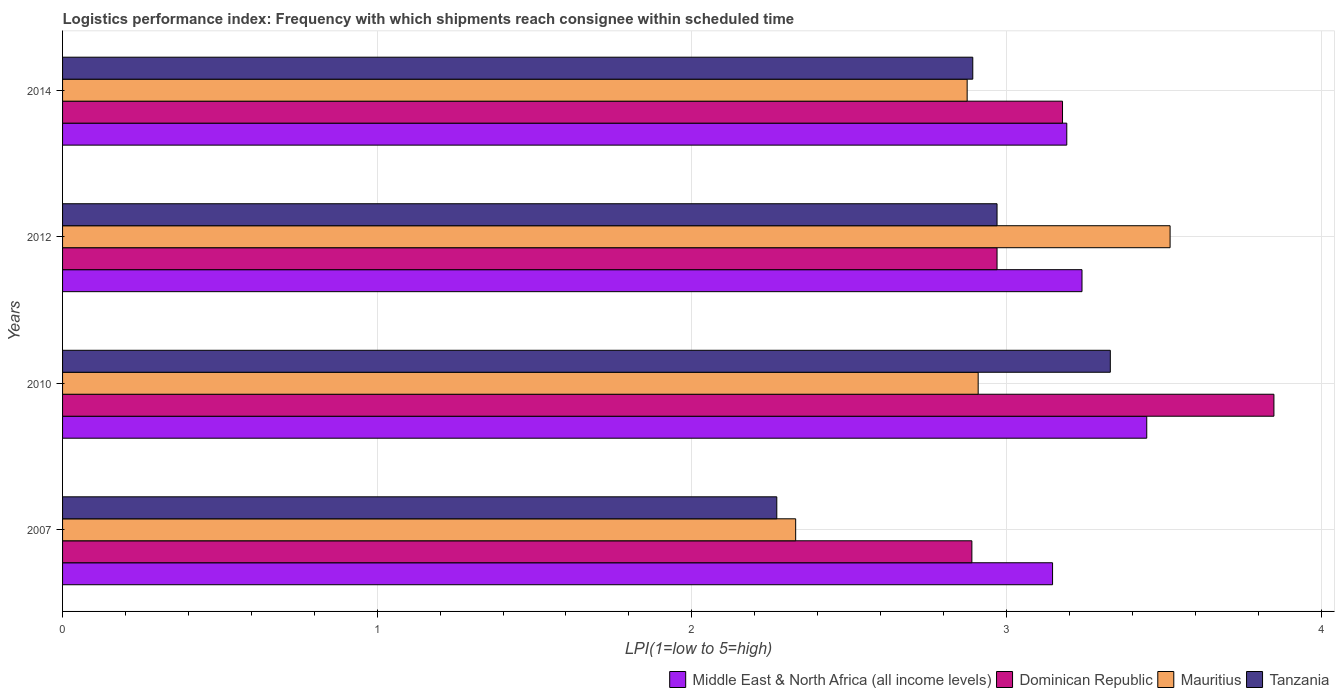Are the number of bars per tick equal to the number of legend labels?
Keep it short and to the point. Yes. Are the number of bars on each tick of the Y-axis equal?
Ensure brevity in your answer.  Yes. How many bars are there on the 4th tick from the top?
Ensure brevity in your answer.  4. In how many cases, is the number of bars for a given year not equal to the number of legend labels?
Offer a terse response. 0. What is the logistics performance index in Tanzania in 2007?
Ensure brevity in your answer.  2.27. Across all years, what is the maximum logistics performance index in Mauritius?
Offer a terse response. 3.52. Across all years, what is the minimum logistics performance index in Dominican Republic?
Your answer should be very brief. 2.89. In which year was the logistics performance index in Middle East & North Africa (all income levels) maximum?
Your response must be concise. 2010. What is the total logistics performance index in Dominican Republic in the graph?
Provide a succinct answer. 12.89. What is the difference between the logistics performance index in Tanzania in 2007 and that in 2014?
Provide a short and direct response. -0.62. What is the difference between the logistics performance index in Mauritius in 2010 and the logistics performance index in Tanzania in 2014?
Provide a short and direct response. 0.02. What is the average logistics performance index in Mauritius per year?
Offer a very short reply. 2.91. In the year 2010, what is the difference between the logistics performance index in Middle East & North Africa (all income levels) and logistics performance index in Mauritius?
Offer a terse response. 0.54. What is the ratio of the logistics performance index in Mauritius in 2007 to that in 2010?
Your response must be concise. 0.8. What is the difference between the highest and the second highest logistics performance index in Dominican Republic?
Ensure brevity in your answer.  0.67. What is the difference between the highest and the lowest logistics performance index in Tanzania?
Your answer should be compact. 1.06. In how many years, is the logistics performance index in Mauritius greater than the average logistics performance index in Mauritius taken over all years?
Give a very brief answer. 2. What does the 3rd bar from the top in 2010 represents?
Give a very brief answer. Dominican Republic. What does the 1st bar from the bottom in 2007 represents?
Provide a short and direct response. Middle East & North Africa (all income levels). Is it the case that in every year, the sum of the logistics performance index in Tanzania and logistics performance index in Middle East & North Africa (all income levels) is greater than the logistics performance index in Dominican Republic?
Your response must be concise. Yes. Are all the bars in the graph horizontal?
Keep it short and to the point. Yes. Are the values on the major ticks of X-axis written in scientific E-notation?
Keep it short and to the point. No. Does the graph contain grids?
Your answer should be compact. Yes. Where does the legend appear in the graph?
Provide a short and direct response. Bottom right. How are the legend labels stacked?
Your answer should be compact. Horizontal. What is the title of the graph?
Provide a succinct answer. Logistics performance index: Frequency with which shipments reach consignee within scheduled time. Does "Middle income" appear as one of the legend labels in the graph?
Offer a very short reply. No. What is the label or title of the X-axis?
Offer a very short reply. LPI(1=low to 5=high). What is the label or title of the Y-axis?
Give a very brief answer. Years. What is the LPI(1=low to 5=high) of Middle East & North Africa (all income levels) in 2007?
Provide a succinct answer. 3.15. What is the LPI(1=low to 5=high) in Dominican Republic in 2007?
Ensure brevity in your answer.  2.89. What is the LPI(1=low to 5=high) in Mauritius in 2007?
Ensure brevity in your answer.  2.33. What is the LPI(1=low to 5=high) of Tanzania in 2007?
Provide a succinct answer. 2.27. What is the LPI(1=low to 5=high) in Middle East & North Africa (all income levels) in 2010?
Ensure brevity in your answer.  3.45. What is the LPI(1=low to 5=high) of Dominican Republic in 2010?
Make the answer very short. 3.85. What is the LPI(1=low to 5=high) in Mauritius in 2010?
Keep it short and to the point. 2.91. What is the LPI(1=low to 5=high) in Tanzania in 2010?
Make the answer very short. 3.33. What is the LPI(1=low to 5=high) of Middle East & North Africa (all income levels) in 2012?
Keep it short and to the point. 3.24. What is the LPI(1=low to 5=high) of Dominican Republic in 2012?
Your answer should be very brief. 2.97. What is the LPI(1=low to 5=high) in Mauritius in 2012?
Provide a succinct answer. 3.52. What is the LPI(1=low to 5=high) of Tanzania in 2012?
Ensure brevity in your answer.  2.97. What is the LPI(1=low to 5=high) in Middle East & North Africa (all income levels) in 2014?
Offer a very short reply. 3.19. What is the LPI(1=low to 5=high) of Dominican Republic in 2014?
Your response must be concise. 3.18. What is the LPI(1=low to 5=high) of Mauritius in 2014?
Your answer should be very brief. 2.88. What is the LPI(1=low to 5=high) of Tanzania in 2014?
Offer a very short reply. 2.89. Across all years, what is the maximum LPI(1=low to 5=high) of Middle East & North Africa (all income levels)?
Provide a succinct answer. 3.45. Across all years, what is the maximum LPI(1=low to 5=high) of Dominican Republic?
Give a very brief answer. 3.85. Across all years, what is the maximum LPI(1=low to 5=high) of Mauritius?
Your answer should be compact. 3.52. Across all years, what is the maximum LPI(1=low to 5=high) of Tanzania?
Provide a short and direct response. 3.33. Across all years, what is the minimum LPI(1=low to 5=high) in Middle East & North Africa (all income levels)?
Your answer should be very brief. 3.15. Across all years, what is the minimum LPI(1=low to 5=high) in Dominican Republic?
Your response must be concise. 2.89. Across all years, what is the minimum LPI(1=low to 5=high) in Mauritius?
Your response must be concise. 2.33. Across all years, what is the minimum LPI(1=low to 5=high) of Tanzania?
Provide a succinct answer. 2.27. What is the total LPI(1=low to 5=high) in Middle East & North Africa (all income levels) in the graph?
Give a very brief answer. 13.02. What is the total LPI(1=low to 5=high) in Dominican Republic in the graph?
Make the answer very short. 12.89. What is the total LPI(1=low to 5=high) of Mauritius in the graph?
Offer a very short reply. 11.63. What is the total LPI(1=low to 5=high) of Tanzania in the graph?
Ensure brevity in your answer.  11.46. What is the difference between the LPI(1=low to 5=high) in Middle East & North Africa (all income levels) in 2007 and that in 2010?
Make the answer very short. -0.3. What is the difference between the LPI(1=low to 5=high) of Dominican Republic in 2007 and that in 2010?
Offer a very short reply. -0.96. What is the difference between the LPI(1=low to 5=high) in Mauritius in 2007 and that in 2010?
Your response must be concise. -0.58. What is the difference between the LPI(1=low to 5=high) of Tanzania in 2007 and that in 2010?
Make the answer very short. -1.06. What is the difference between the LPI(1=low to 5=high) in Middle East & North Africa (all income levels) in 2007 and that in 2012?
Offer a terse response. -0.09. What is the difference between the LPI(1=low to 5=high) in Dominican Republic in 2007 and that in 2012?
Offer a terse response. -0.08. What is the difference between the LPI(1=low to 5=high) of Mauritius in 2007 and that in 2012?
Make the answer very short. -1.19. What is the difference between the LPI(1=low to 5=high) of Middle East & North Africa (all income levels) in 2007 and that in 2014?
Provide a succinct answer. -0.05. What is the difference between the LPI(1=low to 5=high) in Dominican Republic in 2007 and that in 2014?
Keep it short and to the point. -0.29. What is the difference between the LPI(1=low to 5=high) of Mauritius in 2007 and that in 2014?
Ensure brevity in your answer.  -0.55. What is the difference between the LPI(1=low to 5=high) of Tanzania in 2007 and that in 2014?
Keep it short and to the point. -0.62. What is the difference between the LPI(1=low to 5=high) of Middle East & North Africa (all income levels) in 2010 and that in 2012?
Your answer should be compact. 0.21. What is the difference between the LPI(1=low to 5=high) of Mauritius in 2010 and that in 2012?
Give a very brief answer. -0.61. What is the difference between the LPI(1=low to 5=high) in Tanzania in 2010 and that in 2012?
Ensure brevity in your answer.  0.36. What is the difference between the LPI(1=low to 5=high) of Middle East & North Africa (all income levels) in 2010 and that in 2014?
Provide a short and direct response. 0.25. What is the difference between the LPI(1=low to 5=high) of Dominican Republic in 2010 and that in 2014?
Make the answer very short. 0.67. What is the difference between the LPI(1=low to 5=high) in Mauritius in 2010 and that in 2014?
Ensure brevity in your answer.  0.04. What is the difference between the LPI(1=low to 5=high) of Tanzania in 2010 and that in 2014?
Your answer should be very brief. 0.44. What is the difference between the LPI(1=low to 5=high) of Middle East & North Africa (all income levels) in 2012 and that in 2014?
Make the answer very short. 0.05. What is the difference between the LPI(1=low to 5=high) in Dominican Republic in 2012 and that in 2014?
Offer a terse response. -0.21. What is the difference between the LPI(1=low to 5=high) in Mauritius in 2012 and that in 2014?
Your answer should be compact. 0.65. What is the difference between the LPI(1=low to 5=high) of Tanzania in 2012 and that in 2014?
Provide a succinct answer. 0.08. What is the difference between the LPI(1=low to 5=high) in Middle East & North Africa (all income levels) in 2007 and the LPI(1=low to 5=high) in Dominican Republic in 2010?
Your answer should be compact. -0.7. What is the difference between the LPI(1=low to 5=high) of Middle East & North Africa (all income levels) in 2007 and the LPI(1=low to 5=high) of Mauritius in 2010?
Your response must be concise. 0.24. What is the difference between the LPI(1=low to 5=high) of Middle East & North Africa (all income levels) in 2007 and the LPI(1=low to 5=high) of Tanzania in 2010?
Keep it short and to the point. -0.18. What is the difference between the LPI(1=low to 5=high) of Dominican Republic in 2007 and the LPI(1=low to 5=high) of Mauritius in 2010?
Provide a succinct answer. -0.02. What is the difference between the LPI(1=low to 5=high) of Dominican Republic in 2007 and the LPI(1=low to 5=high) of Tanzania in 2010?
Provide a short and direct response. -0.44. What is the difference between the LPI(1=low to 5=high) of Middle East & North Africa (all income levels) in 2007 and the LPI(1=low to 5=high) of Dominican Republic in 2012?
Offer a terse response. 0.18. What is the difference between the LPI(1=low to 5=high) in Middle East & North Africa (all income levels) in 2007 and the LPI(1=low to 5=high) in Mauritius in 2012?
Your answer should be very brief. -0.37. What is the difference between the LPI(1=low to 5=high) of Middle East & North Africa (all income levels) in 2007 and the LPI(1=low to 5=high) of Tanzania in 2012?
Your answer should be very brief. 0.18. What is the difference between the LPI(1=low to 5=high) of Dominican Republic in 2007 and the LPI(1=low to 5=high) of Mauritius in 2012?
Make the answer very short. -0.63. What is the difference between the LPI(1=low to 5=high) of Dominican Republic in 2007 and the LPI(1=low to 5=high) of Tanzania in 2012?
Keep it short and to the point. -0.08. What is the difference between the LPI(1=low to 5=high) of Mauritius in 2007 and the LPI(1=low to 5=high) of Tanzania in 2012?
Your response must be concise. -0.64. What is the difference between the LPI(1=low to 5=high) in Middle East & North Africa (all income levels) in 2007 and the LPI(1=low to 5=high) in Dominican Republic in 2014?
Make the answer very short. -0.03. What is the difference between the LPI(1=low to 5=high) in Middle East & North Africa (all income levels) in 2007 and the LPI(1=low to 5=high) in Mauritius in 2014?
Provide a short and direct response. 0.27. What is the difference between the LPI(1=low to 5=high) in Middle East & North Africa (all income levels) in 2007 and the LPI(1=low to 5=high) in Tanzania in 2014?
Give a very brief answer. 0.25. What is the difference between the LPI(1=low to 5=high) in Dominican Republic in 2007 and the LPI(1=low to 5=high) in Mauritius in 2014?
Your answer should be very brief. 0.01. What is the difference between the LPI(1=low to 5=high) in Dominican Republic in 2007 and the LPI(1=low to 5=high) in Tanzania in 2014?
Offer a very short reply. -0. What is the difference between the LPI(1=low to 5=high) of Mauritius in 2007 and the LPI(1=low to 5=high) of Tanzania in 2014?
Give a very brief answer. -0.56. What is the difference between the LPI(1=low to 5=high) of Middle East & North Africa (all income levels) in 2010 and the LPI(1=low to 5=high) of Dominican Republic in 2012?
Make the answer very short. 0.48. What is the difference between the LPI(1=low to 5=high) of Middle East & North Africa (all income levels) in 2010 and the LPI(1=low to 5=high) of Mauritius in 2012?
Provide a succinct answer. -0.07. What is the difference between the LPI(1=low to 5=high) in Middle East & North Africa (all income levels) in 2010 and the LPI(1=low to 5=high) in Tanzania in 2012?
Keep it short and to the point. 0.48. What is the difference between the LPI(1=low to 5=high) in Dominican Republic in 2010 and the LPI(1=low to 5=high) in Mauritius in 2012?
Provide a short and direct response. 0.33. What is the difference between the LPI(1=low to 5=high) in Dominican Republic in 2010 and the LPI(1=low to 5=high) in Tanzania in 2012?
Your response must be concise. 0.88. What is the difference between the LPI(1=low to 5=high) in Mauritius in 2010 and the LPI(1=low to 5=high) in Tanzania in 2012?
Make the answer very short. -0.06. What is the difference between the LPI(1=low to 5=high) in Middle East & North Africa (all income levels) in 2010 and the LPI(1=low to 5=high) in Dominican Republic in 2014?
Your answer should be compact. 0.27. What is the difference between the LPI(1=low to 5=high) in Middle East & North Africa (all income levels) in 2010 and the LPI(1=low to 5=high) in Mauritius in 2014?
Give a very brief answer. 0.57. What is the difference between the LPI(1=low to 5=high) in Middle East & North Africa (all income levels) in 2010 and the LPI(1=low to 5=high) in Tanzania in 2014?
Provide a short and direct response. 0.55. What is the difference between the LPI(1=low to 5=high) in Dominican Republic in 2010 and the LPI(1=low to 5=high) in Tanzania in 2014?
Make the answer very short. 0.96. What is the difference between the LPI(1=low to 5=high) in Mauritius in 2010 and the LPI(1=low to 5=high) in Tanzania in 2014?
Ensure brevity in your answer.  0.02. What is the difference between the LPI(1=low to 5=high) in Middle East & North Africa (all income levels) in 2012 and the LPI(1=low to 5=high) in Dominican Republic in 2014?
Give a very brief answer. 0.06. What is the difference between the LPI(1=low to 5=high) of Middle East & North Africa (all income levels) in 2012 and the LPI(1=low to 5=high) of Mauritius in 2014?
Offer a terse response. 0.36. What is the difference between the LPI(1=low to 5=high) in Middle East & North Africa (all income levels) in 2012 and the LPI(1=low to 5=high) in Tanzania in 2014?
Offer a very short reply. 0.35. What is the difference between the LPI(1=low to 5=high) in Dominican Republic in 2012 and the LPI(1=low to 5=high) in Mauritius in 2014?
Give a very brief answer. 0.1. What is the difference between the LPI(1=low to 5=high) in Dominican Republic in 2012 and the LPI(1=low to 5=high) in Tanzania in 2014?
Your answer should be very brief. 0.08. What is the difference between the LPI(1=low to 5=high) of Mauritius in 2012 and the LPI(1=low to 5=high) of Tanzania in 2014?
Keep it short and to the point. 0.63. What is the average LPI(1=low to 5=high) of Middle East & North Africa (all income levels) per year?
Your answer should be compact. 3.26. What is the average LPI(1=low to 5=high) in Dominican Republic per year?
Offer a very short reply. 3.22. What is the average LPI(1=low to 5=high) of Mauritius per year?
Offer a terse response. 2.91. What is the average LPI(1=low to 5=high) in Tanzania per year?
Provide a short and direct response. 2.87. In the year 2007, what is the difference between the LPI(1=low to 5=high) of Middle East & North Africa (all income levels) and LPI(1=low to 5=high) of Dominican Republic?
Your answer should be very brief. 0.26. In the year 2007, what is the difference between the LPI(1=low to 5=high) of Middle East & North Africa (all income levels) and LPI(1=low to 5=high) of Mauritius?
Ensure brevity in your answer.  0.82. In the year 2007, what is the difference between the LPI(1=low to 5=high) of Middle East & North Africa (all income levels) and LPI(1=low to 5=high) of Tanzania?
Give a very brief answer. 0.88. In the year 2007, what is the difference between the LPI(1=low to 5=high) of Dominican Republic and LPI(1=low to 5=high) of Mauritius?
Keep it short and to the point. 0.56. In the year 2007, what is the difference between the LPI(1=low to 5=high) in Dominican Republic and LPI(1=low to 5=high) in Tanzania?
Provide a succinct answer. 0.62. In the year 2010, what is the difference between the LPI(1=low to 5=high) of Middle East & North Africa (all income levels) and LPI(1=low to 5=high) of Dominican Republic?
Make the answer very short. -0.4. In the year 2010, what is the difference between the LPI(1=low to 5=high) of Middle East & North Africa (all income levels) and LPI(1=low to 5=high) of Mauritius?
Offer a terse response. 0.54. In the year 2010, what is the difference between the LPI(1=low to 5=high) of Middle East & North Africa (all income levels) and LPI(1=low to 5=high) of Tanzania?
Keep it short and to the point. 0.12. In the year 2010, what is the difference between the LPI(1=low to 5=high) in Dominican Republic and LPI(1=low to 5=high) in Tanzania?
Make the answer very short. 0.52. In the year 2010, what is the difference between the LPI(1=low to 5=high) in Mauritius and LPI(1=low to 5=high) in Tanzania?
Give a very brief answer. -0.42. In the year 2012, what is the difference between the LPI(1=low to 5=high) of Middle East & North Africa (all income levels) and LPI(1=low to 5=high) of Dominican Republic?
Provide a succinct answer. 0.27. In the year 2012, what is the difference between the LPI(1=low to 5=high) of Middle East & North Africa (all income levels) and LPI(1=low to 5=high) of Mauritius?
Keep it short and to the point. -0.28. In the year 2012, what is the difference between the LPI(1=low to 5=high) of Middle East & North Africa (all income levels) and LPI(1=low to 5=high) of Tanzania?
Offer a very short reply. 0.27. In the year 2012, what is the difference between the LPI(1=low to 5=high) of Dominican Republic and LPI(1=low to 5=high) of Mauritius?
Provide a succinct answer. -0.55. In the year 2012, what is the difference between the LPI(1=low to 5=high) of Mauritius and LPI(1=low to 5=high) of Tanzania?
Make the answer very short. 0.55. In the year 2014, what is the difference between the LPI(1=low to 5=high) in Middle East & North Africa (all income levels) and LPI(1=low to 5=high) in Dominican Republic?
Your response must be concise. 0.01. In the year 2014, what is the difference between the LPI(1=low to 5=high) in Middle East & North Africa (all income levels) and LPI(1=low to 5=high) in Mauritius?
Offer a very short reply. 0.32. In the year 2014, what is the difference between the LPI(1=low to 5=high) in Middle East & North Africa (all income levels) and LPI(1=low to 5=high) in Tanzania?
Keep it short and to the point. 0.3. In the year 2014, what is the difference between the LPI(1=low to 5=high) in Dominican Republic and LPI(1=low to 5=high) in Mauritius?
Offer a very short reply. 0.3. In the year 2014, what is the difference between the LPI(1=low to 5=high) of Dominican Republic and LPI(1=low to 5=high) of Tanzania?
Offer a very short reply. 0.29. In the year 2014, what is the difference between the LPI(1=low to 5=high) of Mauritius and LPI(1=low to 5=high) of Tanzania?
Ensure brevity in your answer.  -0.02. What is the ratio of the LPI(1=low to 5=high) of Middle East & North Africa (all income levels) in 2007 to that in 2010?
Offer a terse response. 0.91. What is the ratio of the LPI(1=low to 5=high) in Dominican Republic in 2007 to that in 2010?
Give a very brief answer. 0.75. What is the ratio of the LPI(1=low to 5=high) in Mauritius in 2007 to that in 2010?
Offer a very short reply. 0.8. What is the ratio of the LPI(1=low to 5=high) in Tanzania in 2007 to that in 2010?
Offer a terse response. 0.68. What is the ratio of the LPI(1=low to 5=high) of Middle East & North Africa (all income levels) in 2007 to that in 2012?
Your answer should be very brief. 0.97. What is the ratio of the LPI(1=low to 5=high) of Dominican Republic in 2007 to that in 2012?
Ensure brevity in your answer.  0.97. What is the ratio of the LPI(1=low to 5=high) in Mauritius in 2007 to that in 2012?
Your response must be concise. 0.66. What is the ratio of the LPI(1=low to 5=high) in Tanzania in 2007 to that in 2012?
Ensure brevity in your answer.  0.76. What is the ratio of the LPI(1=low to 5=high) in Middle East & North Africa (all income levels) in 2007 to that in 2014?
Your answer should be very brief. 0.99. What is the ratio of the LPI(1=low to 5=high) of Dominican Republic in 2007 to that in 2014?
Your response must be concise. 0.91. What is the ratio of the LPI(1=low to 5=high) of Mauritius in 2007 to that in 2014?
Provide a short and direct response. 0.81. What is the ratio of the LPI(1=low to 5=high) of Tanzania in 2007 to that in 2014?
Your answer should be compact. 0.78. What is the ratio of the LPI(1=low to 5=high) in Middle East & North Africa (all income levels) in 2010 to that in 2012?
Provide a succinct answer. 1.06. What is the ratio of the LPI(1=low to 5=high) of Dominican Republic in 2010 to that in 2012?
Provide a short and direct response. 1.3. What is the ratio of the LPI(1=low to 5=high) in Mauritius in 2010 to that in 2012?
Your answer should be compact. 0.83. What is the ratio of the LPI(1=low to 5=high) in Tanzania in 2010 to that in 2012?
Keep it short and to the point. 1.12. What is the ratio of the LPI(1=low to 5=high) in Middle East & North Africa (all income levels) in 2010 to that in 2014?
Give a very brief answer. 1.08. What is the ratio of the LPI(1=low to 5=high) of Dominican Republic in 2010 to that in 2014?
Offer a very short reply. 1.21. What is the ratio of the LPI(1=low to 5=high) in Mauritius in 2010 to that in 2014?
Provide a short and direct response. 1.01. What is the ratio of the LPI(1=low to 5=high) in Tanzania in 2010 to that in 2014?
Your answer should be very brief. 1.15. What is the ratio of the LPI(1=low to 5=high) in Middle East & North Africa (all income levels) in 2012 to that in 2014?
Ensure brevity in your answer.  1.02. What is the ratio of the LPI(1=low to 5=high) in Dominican Republic in 2012 to that in 2014?
Your answer should be compact. 0.93. What is the ratio of the LPI(1=low to 5=high) of Mauritius in 2012 to that in 2014?
Provide a succinct answer. 1.22. What is the ratio of the LPI(1=low to 5=high) of Tanzania in 2012 to that in 2014?
Ensure brevity in your answer.  1.03. What is the difference between the highest and the second highest LPI(1=low to 5=high) of Middle East & North Africa (all income levels)?
Your answer should be compact. 0.21. What is the difference between the highest and the second highest LPI(1=low to 5=high) in Dominican Republic?
Your answer should be compact. 0.67. What is the difference between the highest and the second highest LPI(1=low to 5=high) in Mauritius?
Your answer should be very brief. 0.61. What is the difference between the highest and the second highest LPI(1=low to 5=high) in Tanzania?
Your answer should be very brief. 0.36. What is the difference between the highest and the lowest LPI(1=low to 5=high) in Middle East & North Africa (all income levels)?
Make the answer very short. 0.3. What is the difference between the highest and the lowest LPI(1=low to 5=high) of Dominican Republic?
Provide a succinct answer. 0.96. What is the difference between the highest and the lowest LPI(1=low to 5=high) in Mauritius?
Provide a short and direct response. 1.19. What is the difference between the highest and the lowest LPI(1=low to 5=high) of Tanzania?
Give a very brief answer. 1.06. 